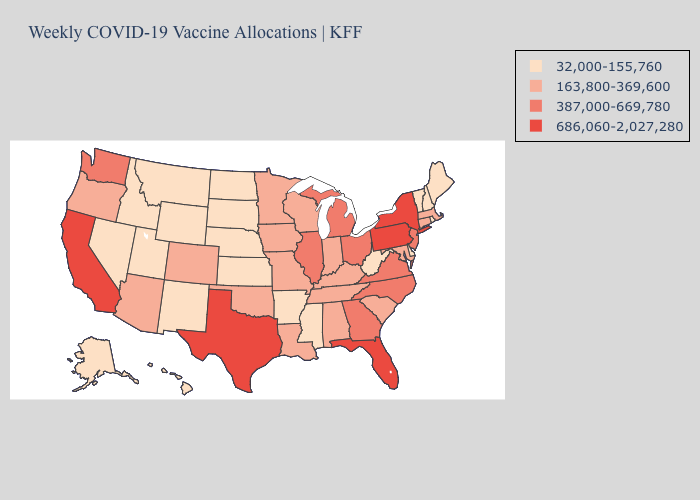What is the lowest value in the South?
Be succinct. 32,000-155,760. Name the states that have a value in the range 163,800-369,600?
Short answer required. Alabama, Arizona, Colorado, Connecticut, Indiana, Iowa, Kentucky, Louisiana, Maryland, Massachusetts, Minnesota, Missouri, Oklahoma, Oregon, South Carolina, Tennessee, Wisconsin. Name the states that have a value in the range 686,060-2,027,280?
Keep it brief. California, Florida, New York, Pennsylvania, Texas. Name the states that have a value in the range 387,000-669,780?
Quick response, please. Georgia, Illinois, Michigan, New Jersey, North Carolina, Ohio, Virginia, Washington. Is the legend a continuous bar?
Keep it brief. No. What is the value of Montana?
Be succinct. 32,000-155,760. Among the states that border Oklahoma , does Kansas have the lowest value?
Short answer required. Yes. Does Texas have the highest value in the USA?
Give a very brief answer. Yes. What is the value of Mississippi?
Keep it brief. 32,000-155,760. Name the states that have a value in the range 387,000-669,780?
Write a very short answer. Georgia, Illinois, Michigan, New Jersey, North Carolina, Ohio, Virginia, Washington. Name the states that have a value in the range 387,000-669,780?
Write a very short answer. Georgia, Illinois, Michigan, New Jersey, North Carolina, Ohio, Virginia, Washington. What is the highest value in states that border Illinois?
Concise answer only. 163,800-369,600. Does Illinois have the lowest value in the USA?
Keep it brief. No. What is the value of Georgia?
Write a very short answer. 387,000-669,780. Does Montana have a lower value than North Carolina?
Keep it brief. Yes. 